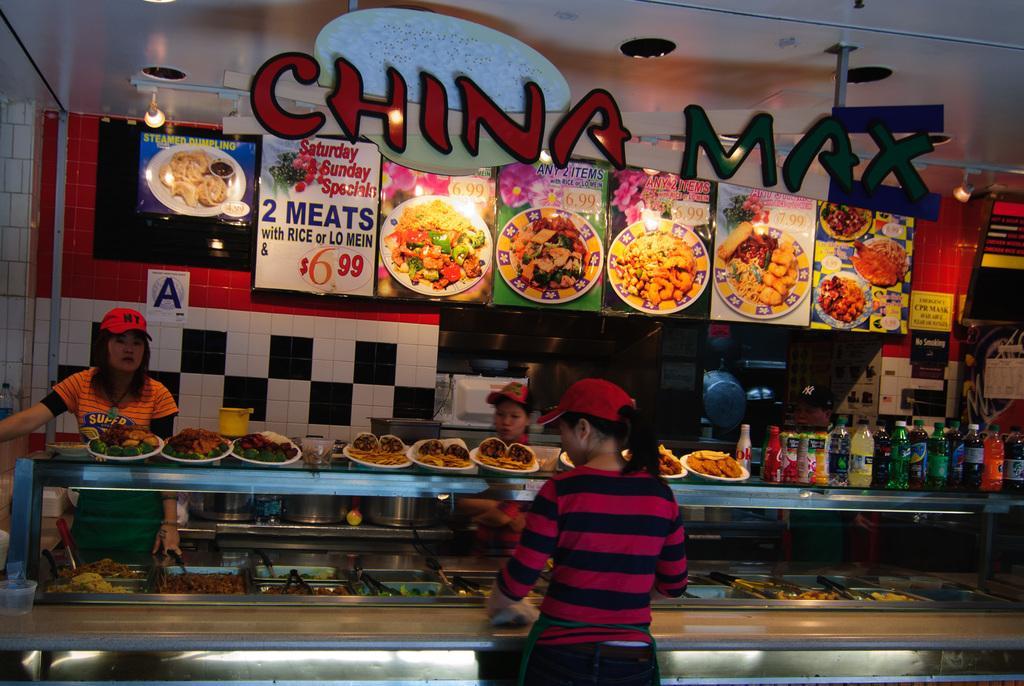Could you give a brief overview of what you see in this image? In this image we can see some food in the plates and a group of bottles which are placed on the surface. We can also see some food and spoons in the containers, some people standing, boards with pictures and text on them, a wall, a pole and a roof with some ceiling lights. 